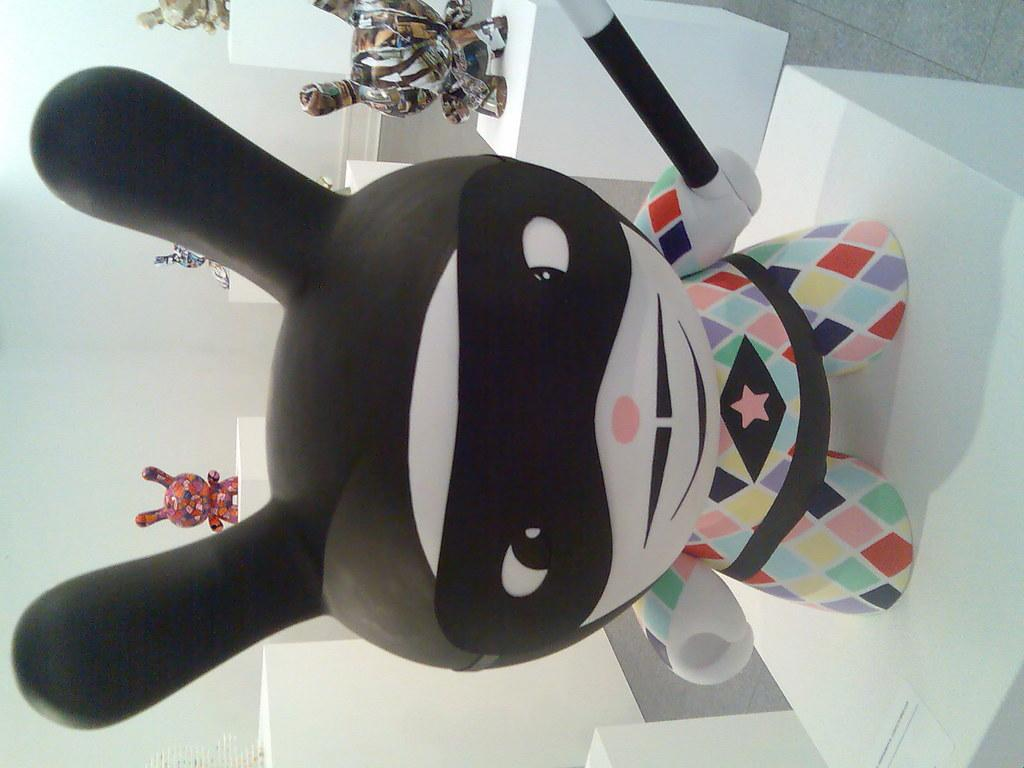What objects are present in the image? There are toys in the image. How are the toys arranged in the image? The toys are placed on white-colored blocks, and each toy is placed separately on each block. What can be seen in the background of the image? There is a wall in the image. What type of button can be seen on the wall in the image? There is no button visible on the wall in the image. How many doors are present in the image? There is no door present in the image; it only features toys on blocks and a wall in the background. 